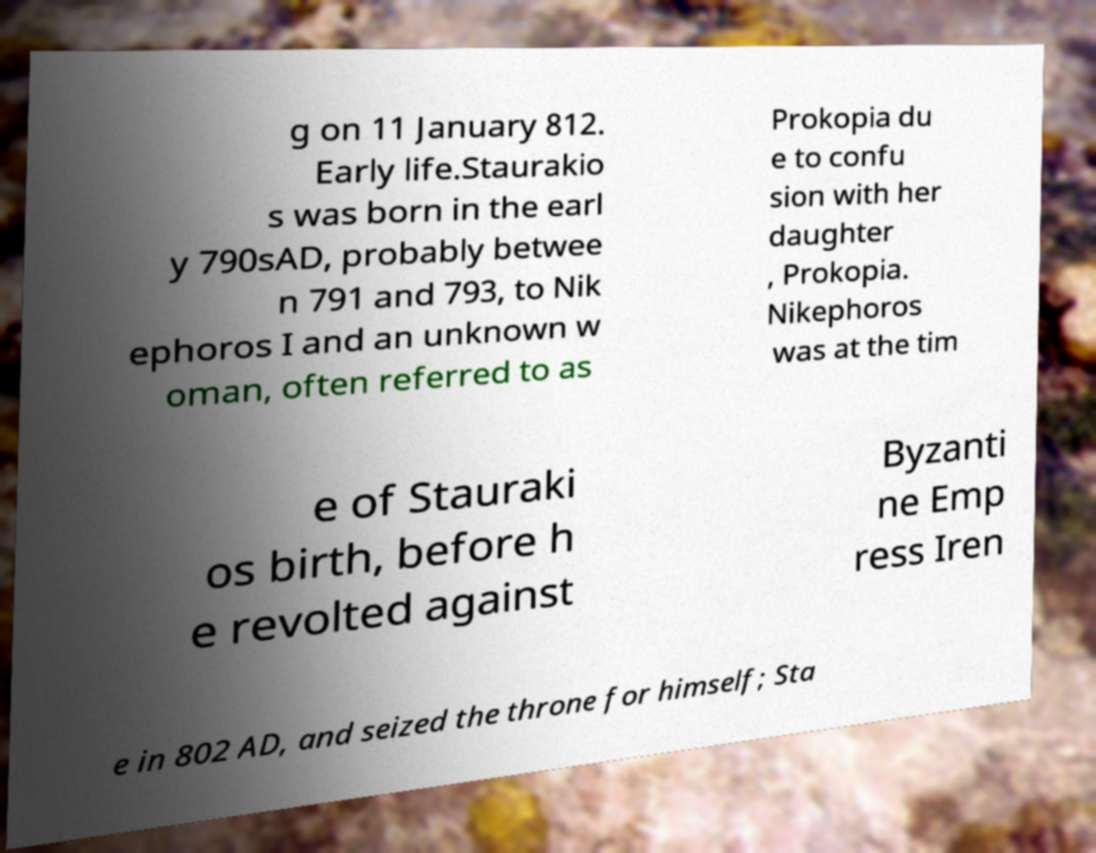Could you assist in decoding the text presented in this image and type it out clearly? g on 11 January 812. Early life.Staurakio s was born in the earl y 790sAD, probably betwee n 791 and 793, to Nik ephoros I and an unknown w oman, often referred to as Prokopia du e to confu sion with her daughter , Prokopia. Nikephoros was at the tim e of Stauraki os birth, before h e revolted against Byzanti ne Emp ress Iren e in 802 AD, and seized the throne for himself; Sta 